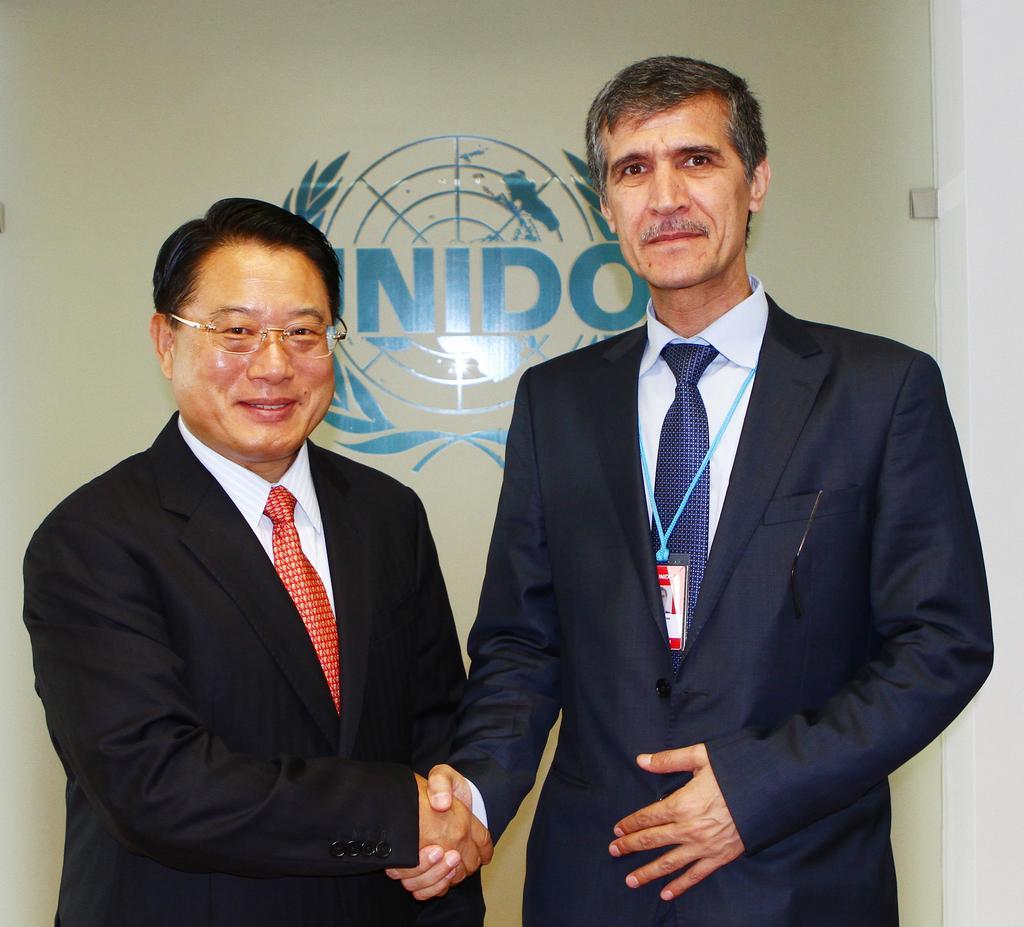How would you summarize this image in a sentence or two? In the center of the image there are two people standing and shaking hands. In the background of the image the there is wall. 